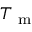<formula> <loc_0><loc_0><loc_500><loc_500>T _ { m }</formula> 